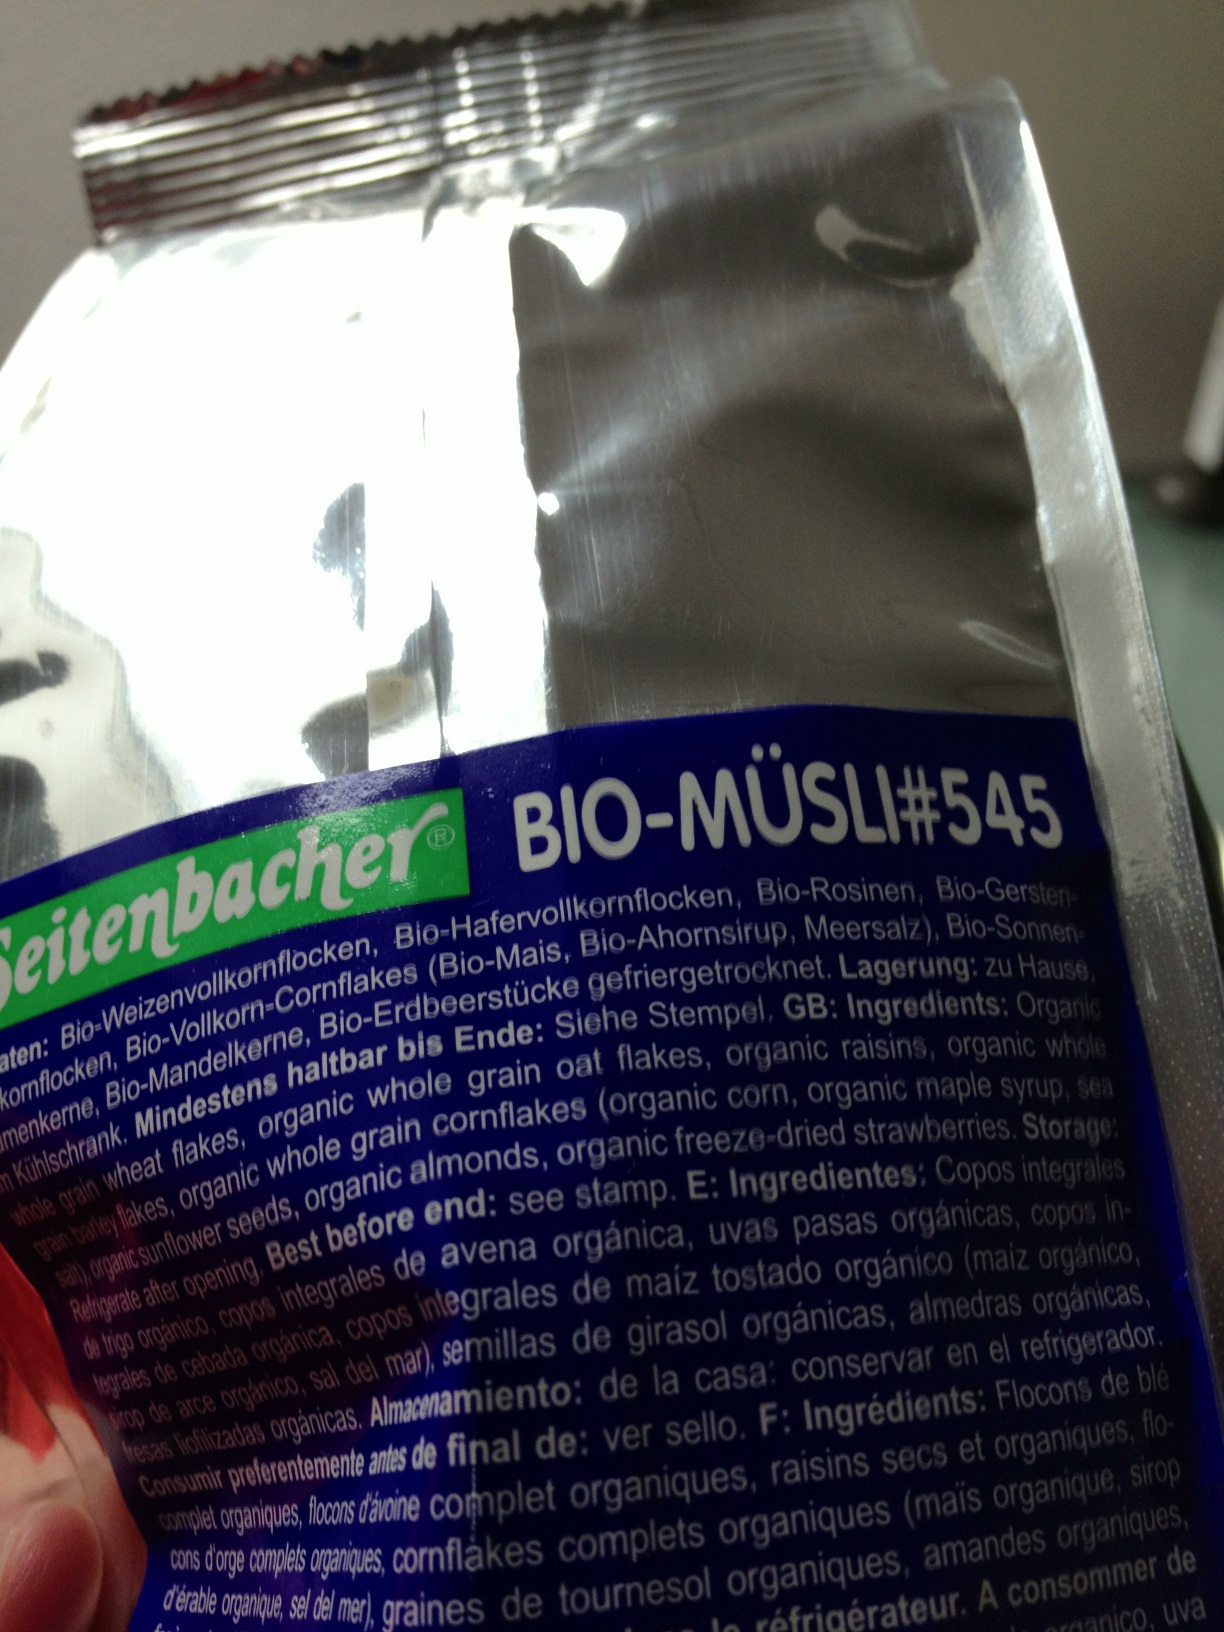Please tell me the expiration date. Thank you. I'm sorry, but the expiration date is not visible in the image provided. Please check the packaging in a well-lit area or look for a date stamp typically found on the edge or back of the packaging. 